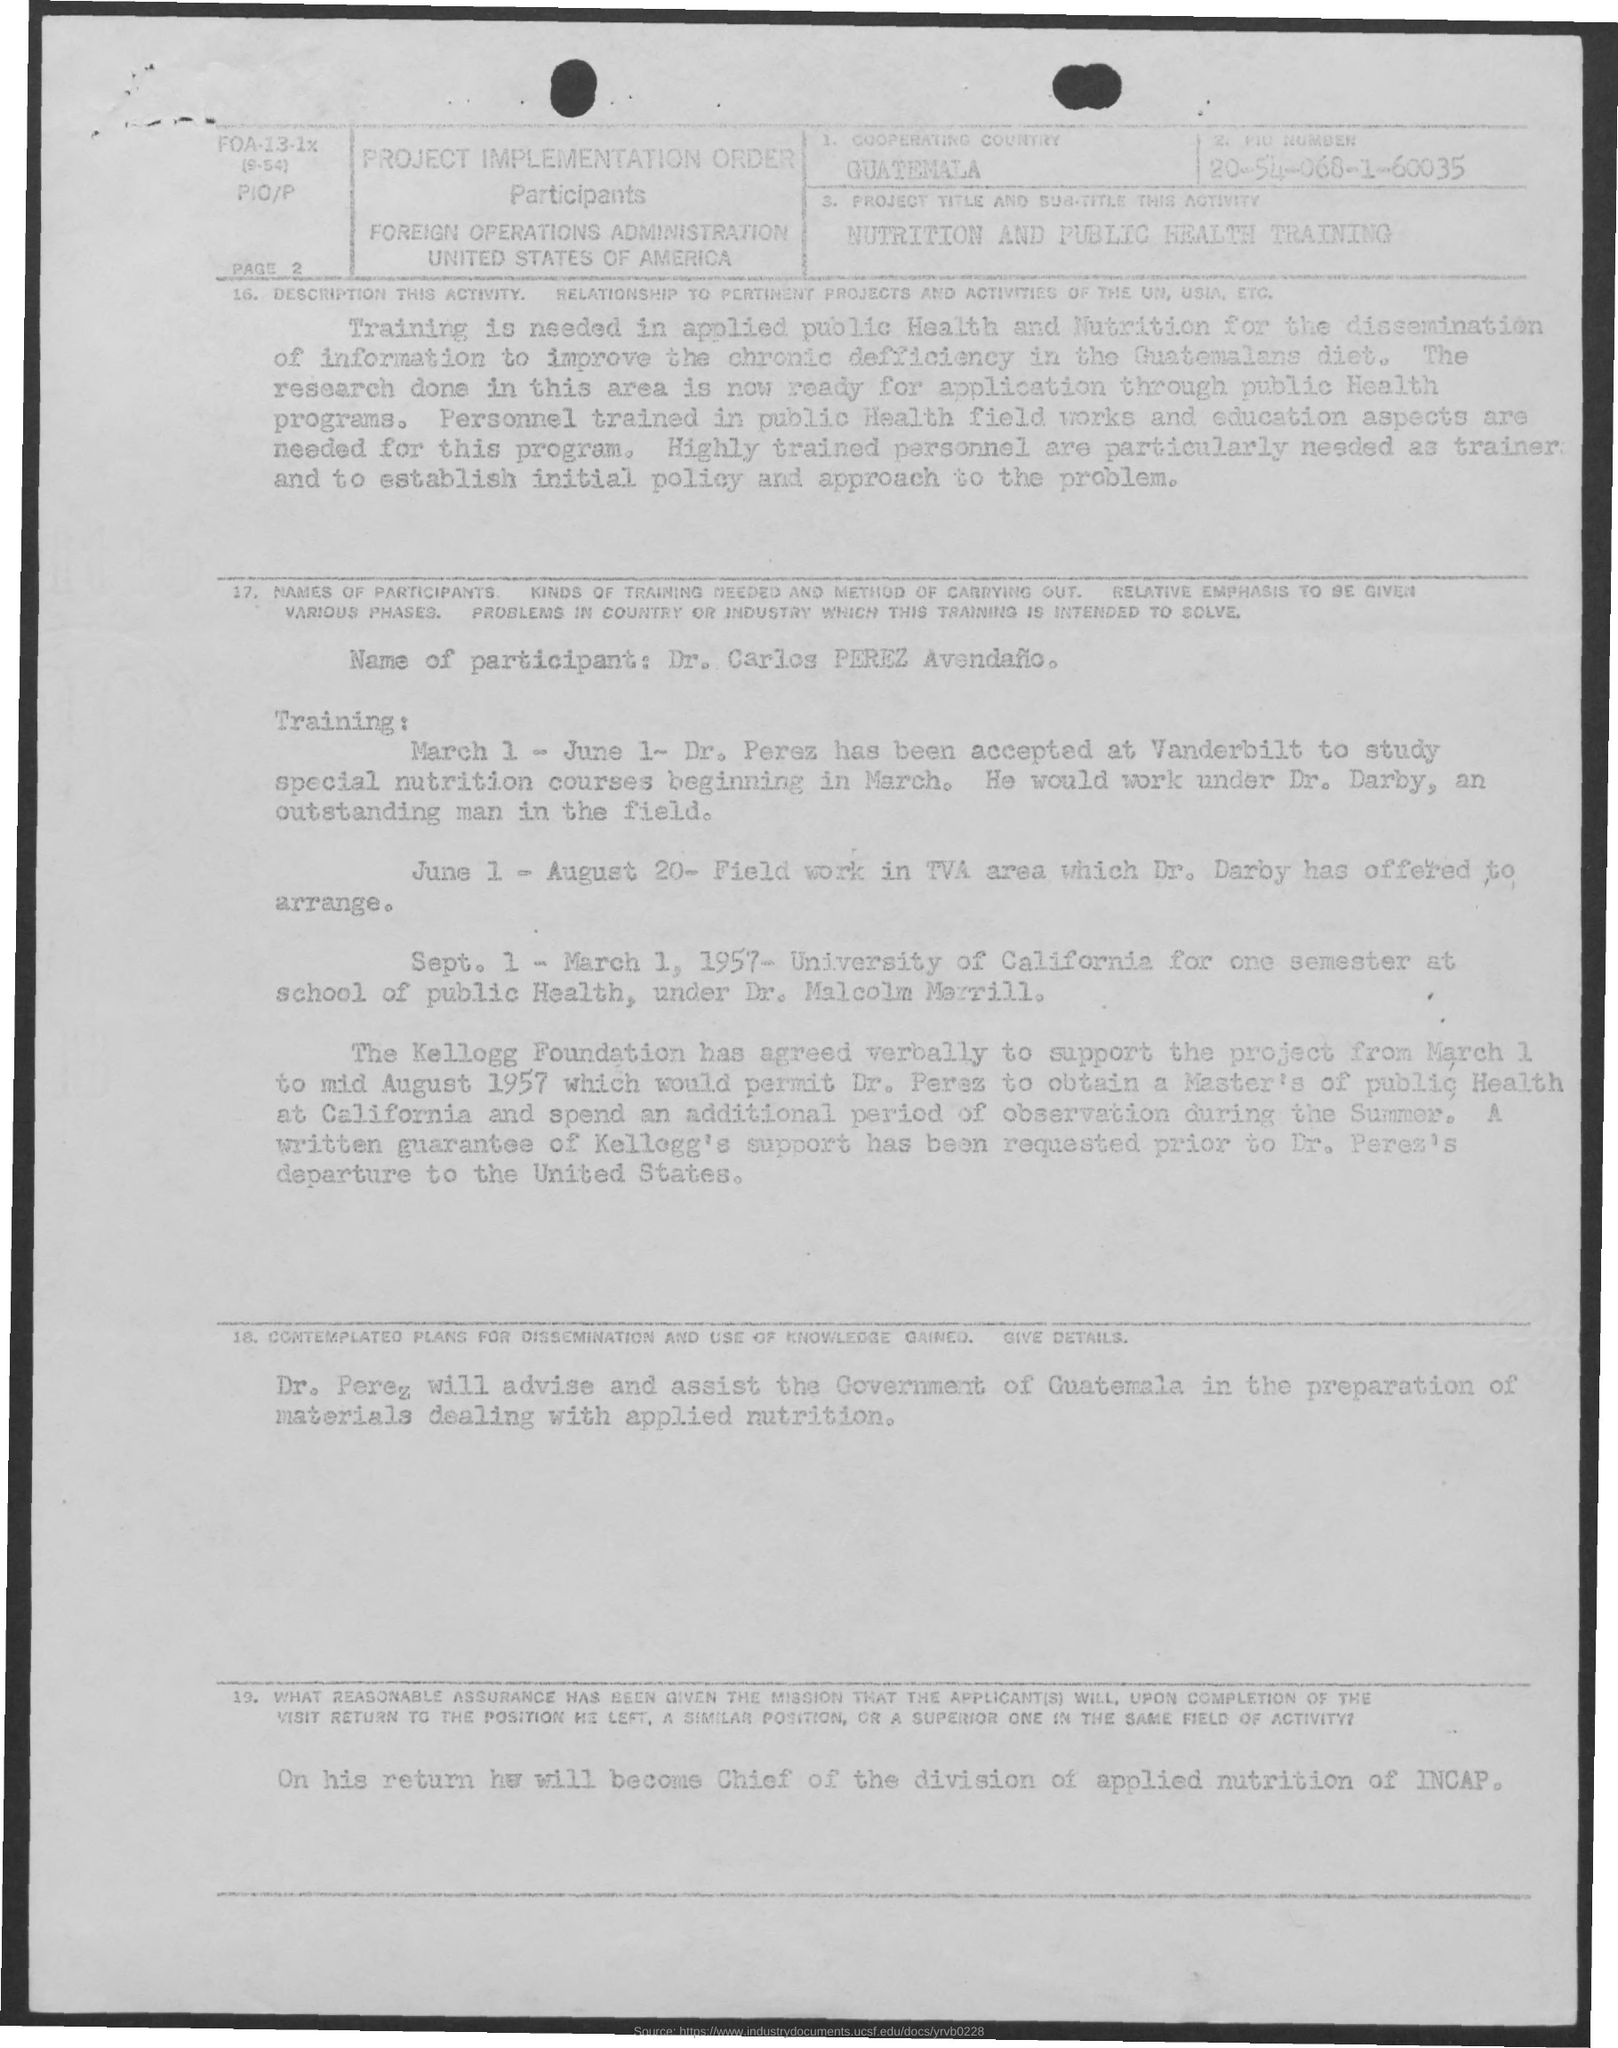Which is the cooperating country?
Your answer should be very brief. Guatemala. 